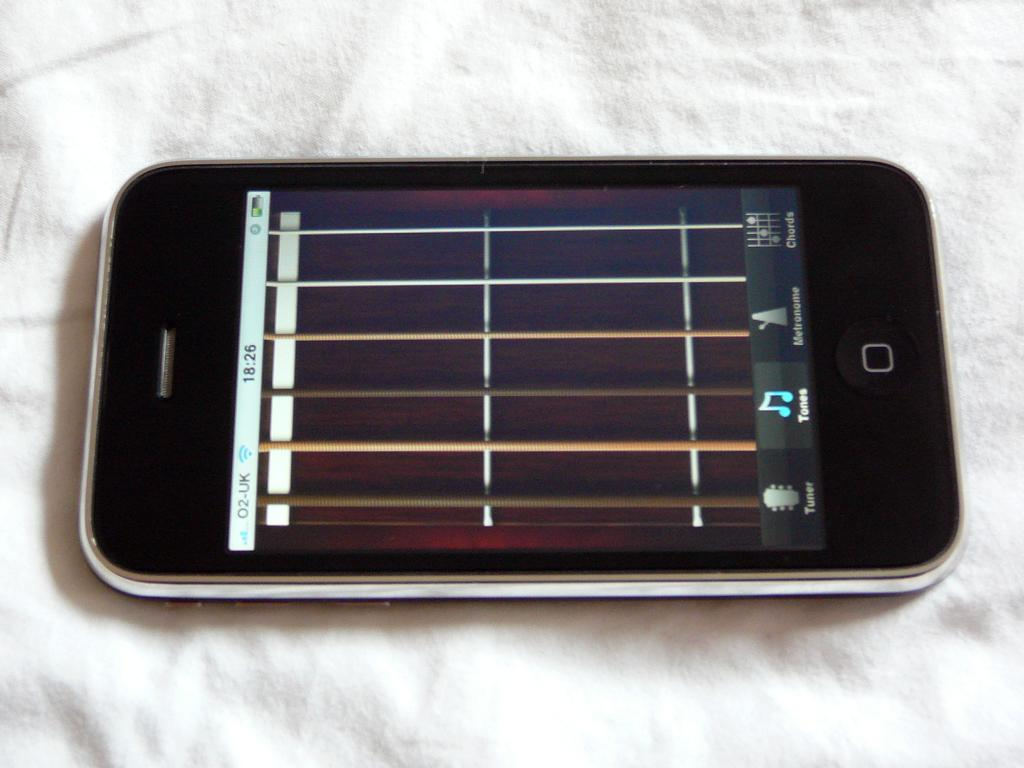<image>
Give a short and clear explanation of the subsequent image. The front of a phone shows that the time is 18:26. 